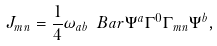<formula> <loc_0><loc_0><loc_500><loc_500>J _ { m n } = \frac { 1 } { 4 } \omega _ { a b } \ B a r \Psi ^ { a } \Gamma ^ { 0 } \Gamma _ { m n } \Psi ^ { b } ,</formula> 